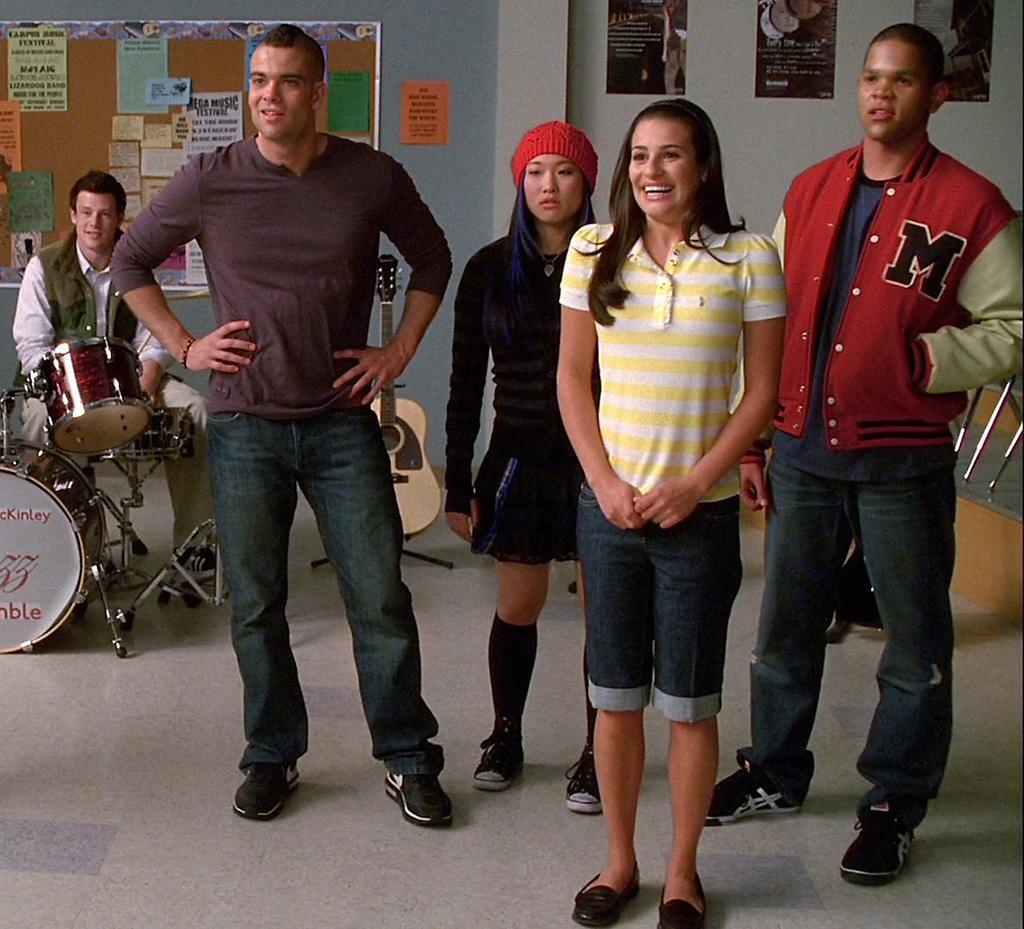Could you give a brief overview of what you see in this image? Here in this picture in the front we can see a group of people standing on the floor over there and behind them we can see a person sitting on a stool with drums in front of him and beside him we can see a guitar present and we can also see a board behind him, on which we can see some pamphlets present and on the wall we can see some posters also present over there. 